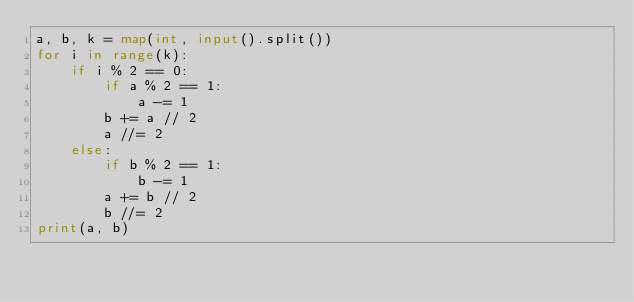<code> <loc_0><loc_0><loc_500><loc_500><_Python_>a, b, k = map(int, input().split())
for i in range(k):
    if i % 2 == 0:
        if a % 2 == 1:
            a -= 1
        b += a // 2
        a //= 2
    else:
        if b % 2 == 1:
            b -= 1
        a += b // 2
        b //= 2
print(a, b)
</code> 